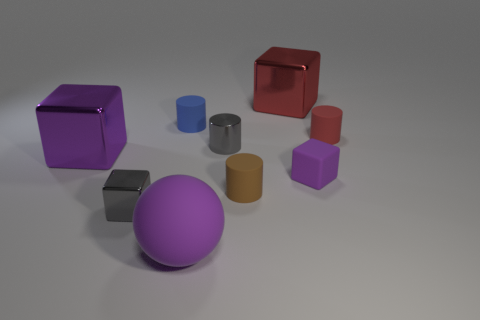Add 1 tiny green balls. How many objects exist? 10 Subtract all balls. How many objects are left? 8 Subtract 1 blue cylinders. How many objects are left? 8 Subtract all rubber things. Subtract all big purple shiny objects. How many objects are left? 3 Add 3 large purple matte spheres. How many large purple matte spheres are left? 4 Add 5 big purple balls. How many big purple balls exist? 6 